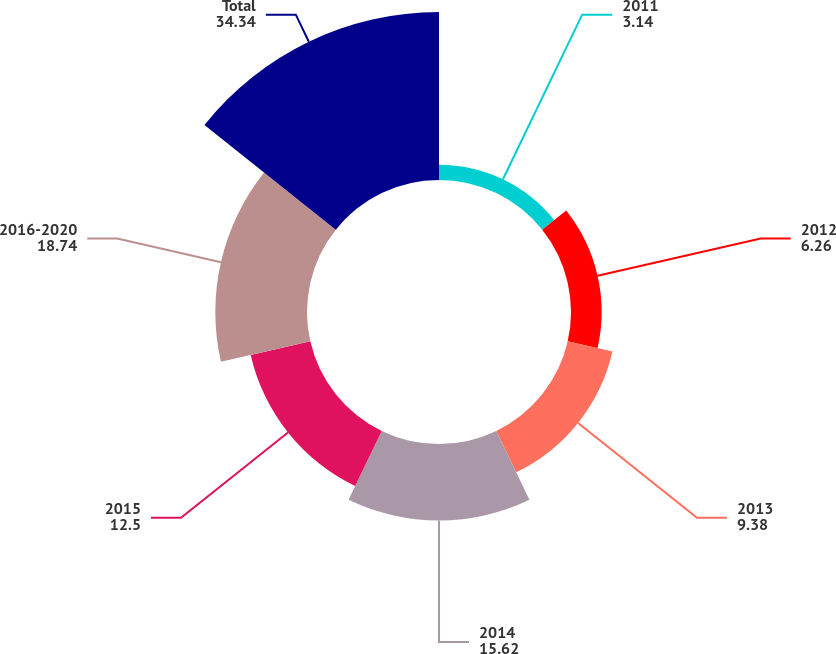Convert chart to OTSL. <chart><loc_0><loc_0><loc_500><loc_500><pie_chart><fcel>2011<fcel>2012<fcel>2013<fcel>2014<fcel>2015<fcel>2016-2020<fcel>Total<nl><fcel>3.14%<fcel>6.26%<fcel>9.38%<fcel>15.62%<fcel>12.5%<fcel>18.74%<fcel>34.34%<nl></chart> 